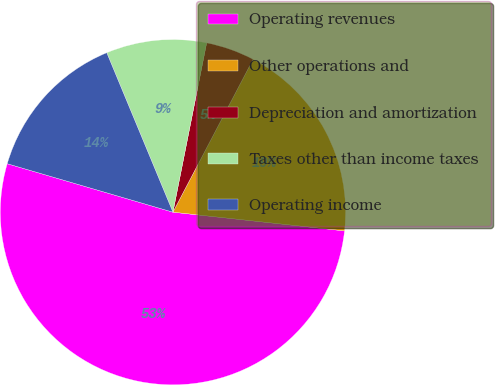Convert chart to OTSL. <chart><loc_0><loc_0><loc_500><loc_500><pie_chart><fcel>Operating revenues<fcel>Other operations and<fcel>Depreciation and amortization<fcel>Taxes other than income taxes<fcel>Operating income<nl><fcel>52.8%<fcel>19.04%<fcel>4.56%<fcel>9.39%<fcel>14.21%<nl></chart> 